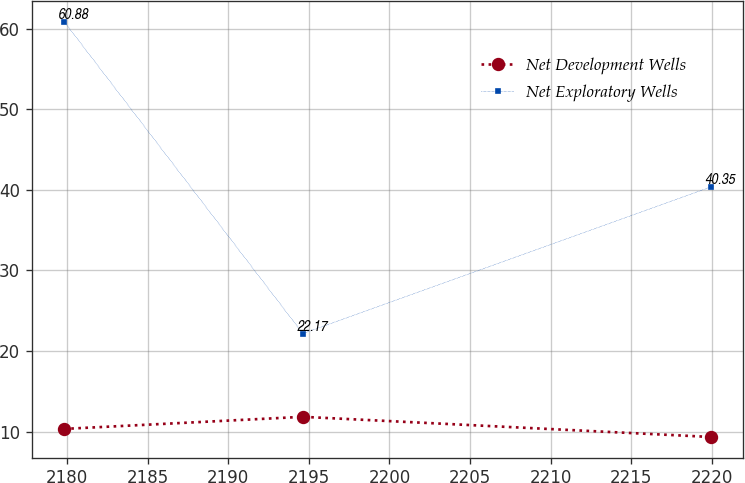<chart> <loc_0><loc_0><loc_500><loc_500><line_chart><ecel><fcel>Net Development Wells<fcel>Net Exploratory Wells<nl><fcel>2179.82<fcel>10.34<fcel>60.88<nl><fcel>2194.63<fcel>11.84<fcel>22.17<nl><fcel>2219.93<fcel>9.34<fcel>40.35<nl></chart> 